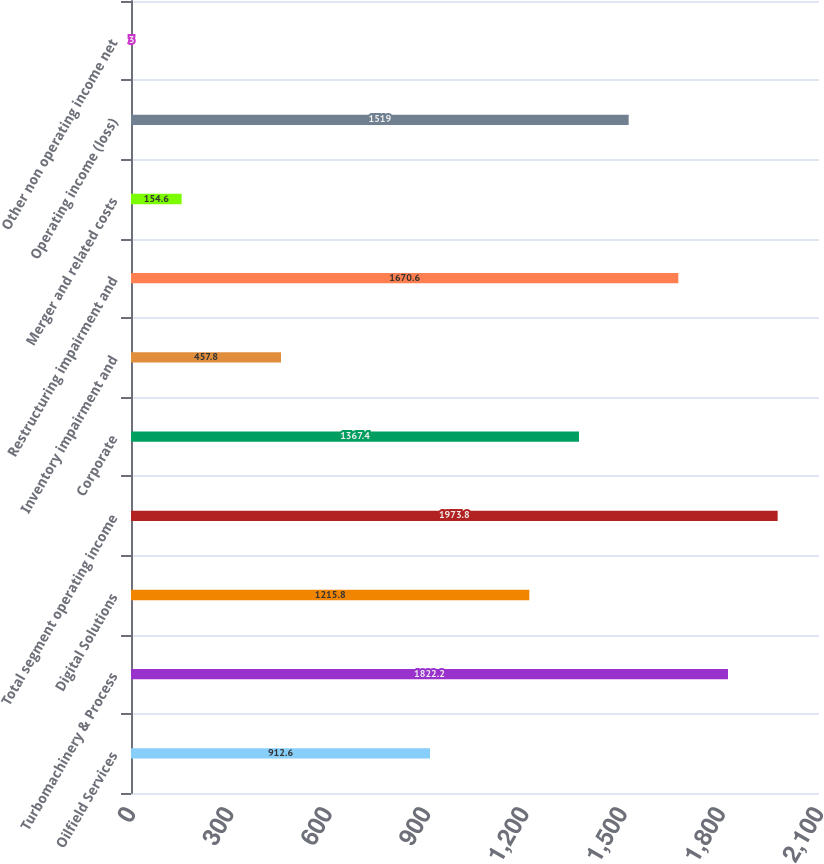Convert chart to OTSL. <chart><loc_0><loc_0><loc_500><loc_500><bar_chart><fcel>Oilfield Services<fcel>Turbomachinery & Process<fcel>Digital Solutions<fcel>Total segment operating income<fcel>Corporate<fcel>Inventory impairment and<fcel>Restructuring impairment and<fcel>Merger and related costs<fcel>Operating income (loss)<fcel>Other non operating income net<nl><fcel>912.6<fcel>1822.2<fcel>1215.8<fcel>1973.8<fcel>1367.4<fcel>457.8<fcel>1670.6<fcel>154.6<fcel>1519<fcel>3<nl></chart> 